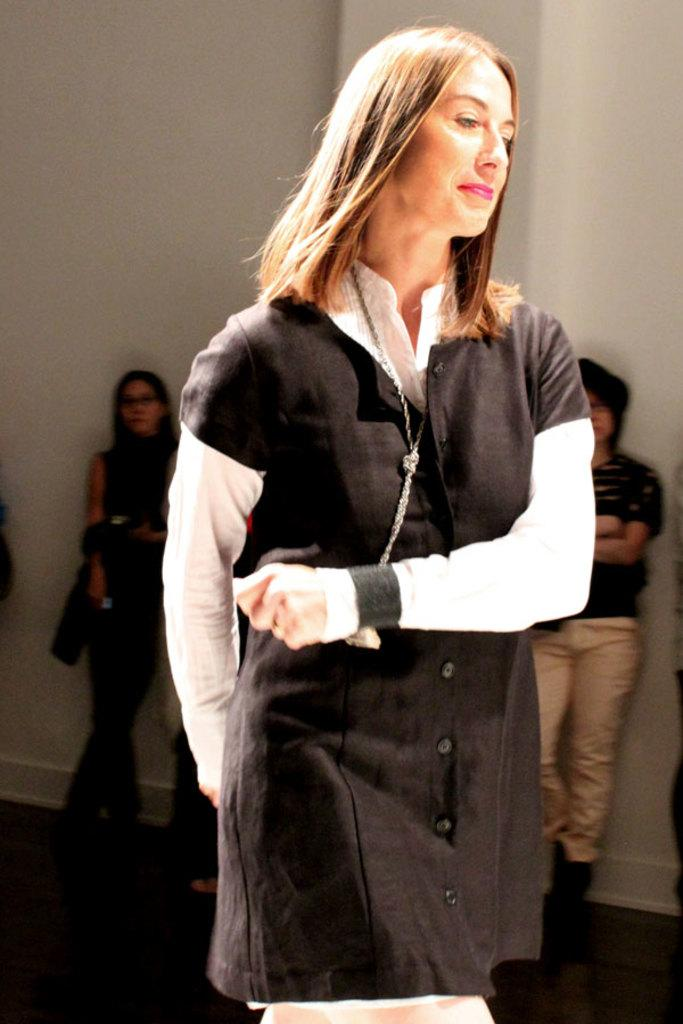What is the woman in the image wearing? The woman is wearing a black and white dress. Are there any other people in the image besides the woman? Yes, there are people standing behind the woman. What can be seen in the background of the image? There is a wall in the background of the image. How many chains can be seen on the woman's dress in the image? There are no chains visible on the woman's dress in the image. 